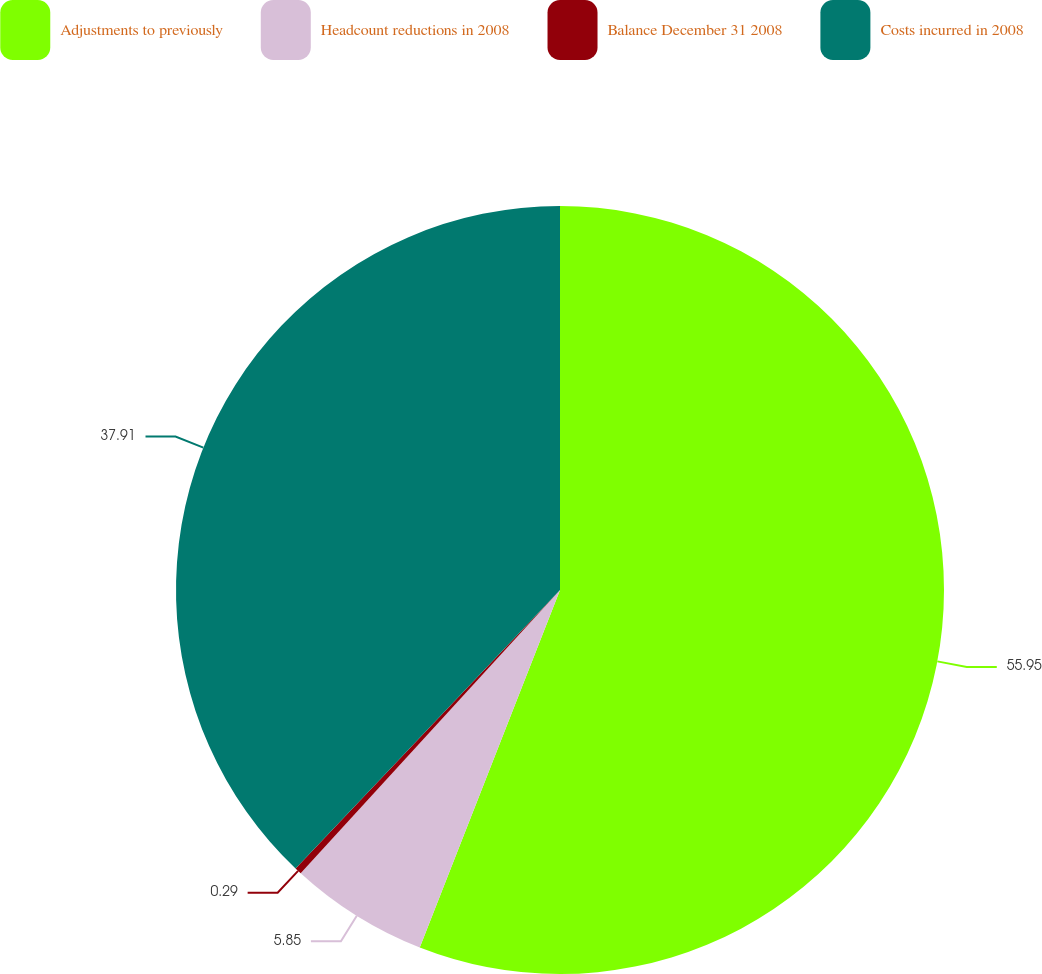Convert chart. <chart><loc_0><loc_0><loc_500><loc_500><pie_chart><fcel>Adjustments to previously<fcel>Headcount reductions in 2008<fcel>Balance December 31 2008<fcel>Costs incurred in 2008<nl><fcel>55.95%<fcel>5.85%<fcel>0.29%<fcel>37.91%<nl></chart> 